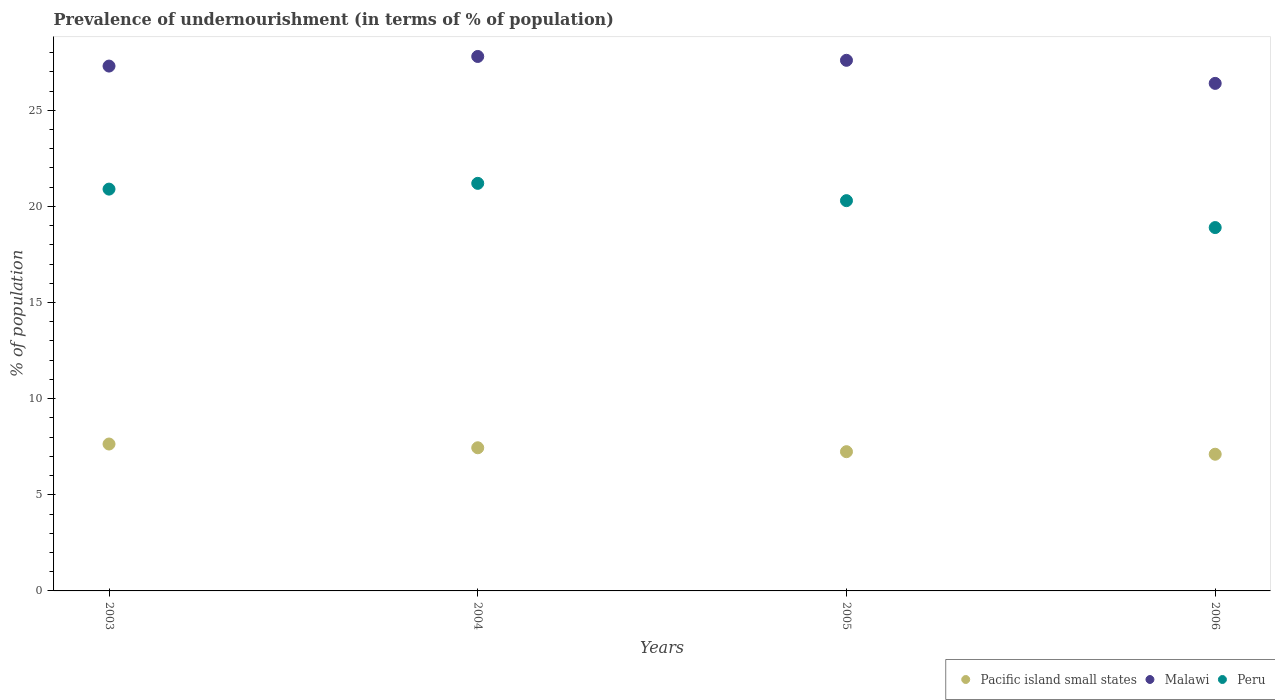What is the percentage of undernourished population in Peru in 2004?
Ensure brevity in your answer.  21.2. Across all years, what is the maximum percentage of undernourished population in Peru?
Offer a very short reply. 21.2. Across all years, what is the minimum percentage of undernourished population in Malawi?
Give a very brief answer. 26.4. In which year was the percentage of undernourished population in Malawi maximum?
Provide a short and direct response. 2004. In which year was the percentage of undernourished population in Pacific island small states minimum?
Your answer should be very brief. 2006. What is the total percentage of undernourished population in Pacific island small states in the graph?
Ensure brevity in your answer.  29.44. What is the difference between the percentage of undernourished population in Pacific island small states in 2005 and that in 2006?
Your response must be concise. 0.13. What is the difference between the percentage of undernourished population in Peru in 2003 and the percentage of undernourished population in Malawi in 2005?
Your response must be concise. -6.7. What is the average percentage of undernourished population in Malawi per year?
Make the answer very short. 27.27. In the year 2004, what is the difference between the percentage of undernourished population in Peru and percentage of undernourished population in Malawi?
Give a very brief answer. -6.6. What is the ratio of the percentage of undernourished population in Malawi in 2004 to that in 2005?
Your answer should be very brief. 1.01. Is the percentage of undernourished population in Peru in 2005 less than that in 2006?
Offer a terse response. No. What is the difference between the highest and the second highest percentage of undernourished population in Peru?
Make the answer very short. 0.3. What is the difference between the highest and the lowest percentage of undernourished population in Peru?
Offer a terse response. 2.3. In how many years, is the percentage of undernourished population in Peru greater than the average percentage of undernourished population in Peru taken over all years?
Provide a succinct answer. 2. Is it the case that in every year, the sum of the percentage of undernourished population in Peru and percentage of undernourished population in Malawi  is greater than the percentage of undernourished population in Pacific island small states?
Make the answer very short. Yes. Does the percentage of undernourished population in Malawi monotonically increase over the years?
Ensure brevity in your answer.  No. Is the percentage of undernourished population in Malawi strictly greater than the percentage of undernourished population in Pacific island small states over the years?
Your answer should be compact. Yes. What is the difference between two consecutive major ticks on the Y-axis?
Make the answer very short. 5. Does the graph contain grids?
Your answer should be very brief. No. Where does the legend appear in the graph?
Give a very brief answer. Bottom right. How are the legend labels stacked?
Offer a terse response. Horizontal. What is the title of the graph?
Offer a very short reply. Prevalence of undernourishment (in terms of % of population). Does "Sudan" appear as one of the legend labels in the graph?
Your answer should be very brief. No. What is the label or title of the X-axis?
Make the answer very short. Years. What is the label or title of the Y-axis?
Offer a very short reply. % of population. What is the % of population in Pacific island small states in 2003?
Give a very brief answer. 7.64. What is the % of population in Malawi in 2003?
Offer a very short reply. 27.3. What is the % of population of Peru in 2003?
Keep it short and to the point. 20.9. What is the % of population of Pacific island small states in 2004?
Give a very brief answer. 7.45. What is the % of population of Malawi in 2004?
Offer a very short reply. 27.8. What is the % of population in Peru in 2004?
Provide a succinct answer. 21.2. What is the % of population in Pacific island small states in 2005?
Provide a short and direct response. 7.24. What is the % of population in Malawi in 2005?
Provide a succinct answer. 27.6. What is the % of population of Peru in 2005?
Offer a very short reply. 20.3. What is the % of population in Pacific island small states in 2006?
Your answer should be very brief. 7.11. What is the % of population of Malawi in 2006?
Ensure brevity in your answer.  26.4. What is the % of population of Peru in 2006?
Make the answer very short. 18.9. Across all years, what is the maximum % of population in Pacific island small states?
Your response must be concise. 7.64. Across all years, what is the maximum % of population in Malawi?
Your response must be concise. 27.8. Across all years, what is the maximum % of population of Peru?
Provide a short and direct response. 21.2. Across all years, what is the minimum % of population in Pacific island small states?
Offer a very short reply. 7.11. Across all years, what is the minimum % of population of Malawi?
Give a very brief answer. 26.4. What is the total % of population in Pacific island small states in the graph?
Ensure brevity in your answer.  29.44. What is the total % of population in Malawi in the graph?
Your response must be concise. 109.1. What is the total % of population of Peru in the graph?
Your response must be concise. 81.3. What is the difference between the % of population in Pacific island small states in 2003 and that in 2004?
Give a very brief answer. 0.19. What is the difference between the % of population of Malawi in 2003 and that in 2004?
Offer a very short reply. -0.5. What is the difference between the % of population of Pacific island small states in 2003 and that in 2005?
Make the answer very short. 0.4. What is the difference between the % of population in Malawi in 2003 and that in 2005?
Your answer should be very brief. -0.3. What is the difference between the % of population of Peru in 2003 and that in 2005?
Make the answer very short. 0.6. What is the difference between the % of population of Pacific island small states in 2003 and that in 2006?
Keep it short and to the point. 0.53. What is the difference between the % of population in Pacific island small states in 2004 and that in 2005?
Ensure brevity in your answer.  0.2. What is the difference between the % of population in Pacific island small states in 2004 and that in 2006?
Ensure brevity in your answer.  0.34. What is the difference between the % of population in Pacific island small states in 2005 and that in 2006?
Your answer should be compact. 0.13. What is the difference between the % of population in Pacific island small states in 2003 and the % of population in Malawi in 2004?
Keep it short and to the point. -20.16. What is the difference between the % of population in Pacific island small states in 2003 and the % of population in Peru in 2004?
Keep it short and to the point. -13.56. What is the difference between the % of population of Malawi in 2003 and the % of population of Peru in 2004?
Give a very brief answer. 6.1. What is the difference between the % of population in Pacific island small states in 2003 and the % of population in Malawi in 2005?
Your answer should be very brief. -19.96. What is the difference between the % of population of Pacific island small states in 2003 and the % of population of Peru in 2005?
Your answer should be compact. -12.66. What is the difference between the % of population of Malawi in 2003 and the % of population of Peru in 2005?
Your answer should be very brief. 7. What is the difference between the % of population of Pacific island small states in 2003 and the % of population of Malawi in 2006?
Offer a very short reply. -18.76. What is the difference between the % of population of Pacific island small states in 2003 and the % of population of Peru in 2006?
Provide a succinct answer. -11.26. What is the difference between the % of population in Malawi in 2003 and the % of population in Peru in 2006?
Provide a succinct answer. 8.4. What is the difference between the % of population in Pacific island small states in 2004 and the % of population in Malawi in 2005?
Your answer should be compact. -20.15. What is the difference between the % of population of Pacific island small states in 2004 and the % of population of Peru in 2005?
Your answer should be very brief. -12.85. What is the difference between the % of population in Pacific island small states in 2004 and the % of population in Malawi in 2006?
Provide a short and direct response. -18.95. What is the difference between the % of population in Pacific island small states in 2004 and the % of population in Peru in 2006?
Your answer should be compact. -11.45. What is the difference between the % of population in Malawi in 2004 and the % of population in Peru in 2006?
Give a very brief answer. 8.9. What is the difference between the % of population of Pacific island small states in 2005 and the % of population of Malawi in 2006?
Your answer should be compact. -19.16. What is the difference between the % of population of Pacific island small states in 2005 and the % of population of Peru in 2006?
Make the answer very short. -11.66. What is the average % of population in Pacific island small states per year?
Offer a very short reply. 7.36. What is the average % of population in Malawi per year?
Your answer should be very brief. 27.27. What is the average % of population of Peru per year?
Provide a succinct answer. 20.32. In the year 2003, what is the difference between the % of population in Pacific island small states and % of population in Malawi?
Offer a terse response. -19.66. In the year 2003, what is the difference between the % of population of Pacific island small states and % of population of Peru?
Your response must be concise. -13.26. In the year 2004, what is the difference between the % of population of Pacific island small states and % of population of Malawi?
Your response must be concise. -20.35. In the year 2004, what is the difference between the % of population in Pacific island small states and % of population in Peru?
Keep it short and to the point. -13.75. In the year 2004, what is the difference between the % of population in Malawi and % of population in Peru?
Give a very brief answer. 6.6. In the year 2005, what is the difference between the % of population of Pacific island small states and % of population of Malawi?
Keep it short and to the point. -20.36. In the year 2005, what is the difference between the % of population in Pacific island small states and % of population in Peru?
Ensure brevity in your answer.  -13.06. In the year 2005, what is the difference between the % of population of Malawi and % of population of Peru?
Keep it short and to the point. 7.3. In the year 2006, what is the difference between the % of population of Pacific island small states and % of population of Malawi?
Ensure brevity in your answer.  -19.29. In the year 2006, what is the difference between the % of population in Pacific island small states and % of population in Peru?
Offer a very short reply. -11.79. What is the ratio of the % of population in Pacific island small states in 2003 to that in 2004?
Offer a very short reply. 1.03. What is the ratio of the % of population in Malawi in 2003 to that in 2004?
Keep it short and to the point. 0.98. What is the ratio of the % of population of Peru in 2003 to that in 2004?
Offer a very short reply. 0.99. What is the ratio of the % of population in Pacific island small states in 2003 to that in 2005?
Provide a succinct answer. 1.05. What is the ratio of the % of population in Malawi in 2003 to that in 2005?
Provide a short and direct response. 0.99. What is the ratio of the % of population of Peru in 2003 to that in 2005?
Keep it short and to the point. 1.03. What is the ratio of the % of population of Pacific island small states in 2003 to that in 2006?
Your answer should be very brief. 1.07. What is the ratio of the % of population in Malawi in 2003 to that in 2006?
Provide a short and direct response. 1.03. What is the ratio of the % of population of Peru in 2003 to that in 2006?
Your response must be concise. 1.11. What is the ratio of the % of population of Pacific island small states in 2004 to that in 2005?
Offer a very short reply. 1.03. What is the ratio of the % of population of Peru in 2004 to that in 2005?
Your answer should be very brief. 1.04. What is the ratio of the % of population in Pacific island small states in 2004 to that in 2006?
Provide a succinct answer. 1.05. What is the ratio of the % of population of Malawi in 2004 to that in 2006?
Provide a short and direct response. 1.05. What is the ratio of the % of population of Peru in 2004 to that in 2006?
Ensure brevity in your answer.  1.12. What is the ratio of the % of population in Pacific island small states in 2005 to that in 2006?
Give a very brief answer. 1.02. What is the ratio of the % of population in Malawi in 2005 to that in 2006?
Offer a very short reply. 1.05. What is the ratio of the % of population of Peru in 2005 to that in 2006?
Give a very brief answer. 1.07. What is the difference between the highest and the second highest % of population in Pacific island small states?
Your response must be concise. 0.19. What is the difference between the highest and the lowest % of population of Pacific island small states?
Provide a short and direct response. 0.53. What is the difference between the highest and the lowest % of population of Malawi?
Keep it short and to the point. 1.4. What is the difference between the highest and the lowest % of population in Peru?
Give a very brief answer. 2.3. 